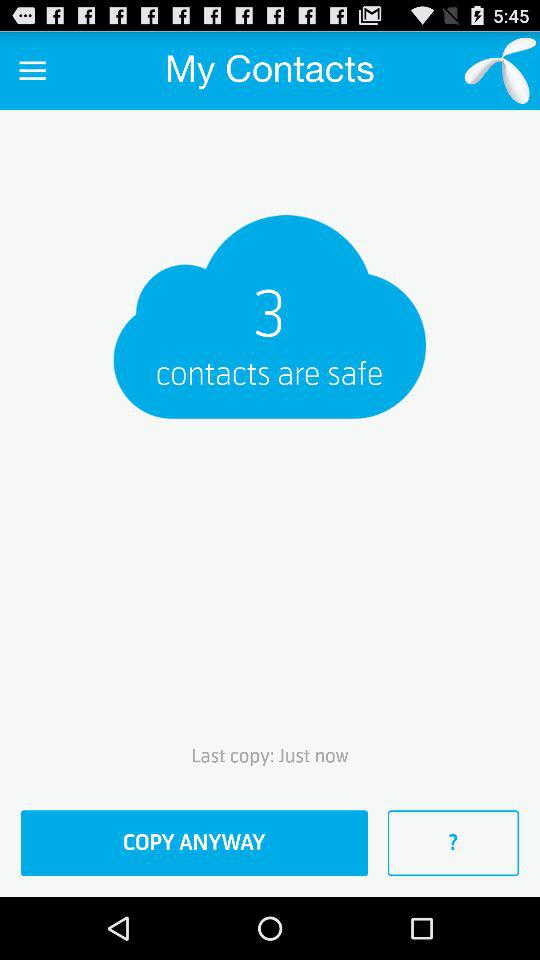How many contacts are safe?
Answer the question using a single word or phrase. 3 